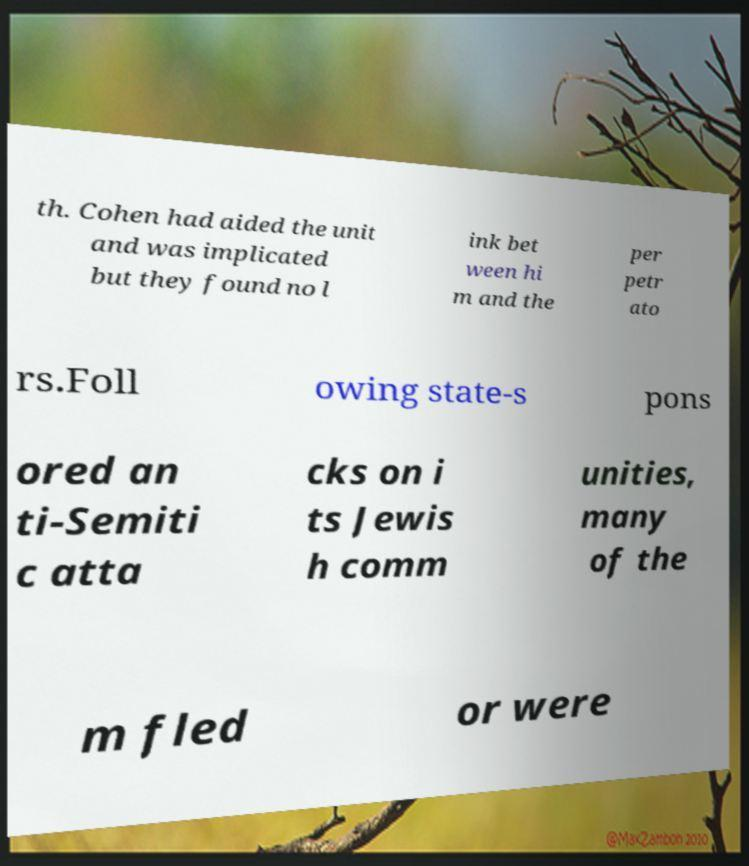What messages or text are displayed in this image? I need them in a readable, typed format. th. Cohen had aided the unit and was implicated but they found no l ink bet ween hi m and the per petr ato rs.Foll owing state-s pons ored an ti-Semiti c atta cks on i ts Jewis h comm unities, many of the m fled or were 